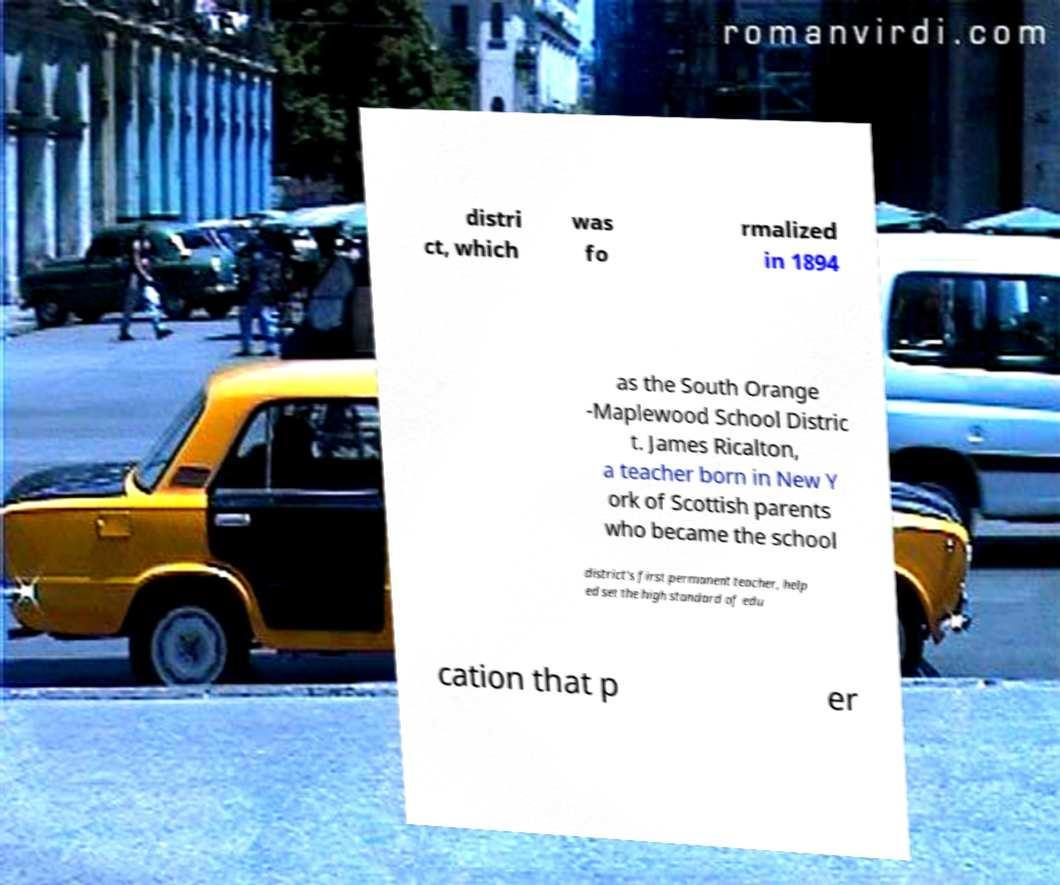Please read and relay the text visible in this image. What does it say? distri ct, which was fo rmalized in 1894 as the South Orange -Maplewood School Distric t. James Ricalton, a teacher born in New Y ork of Scottish parents who became the school district's first permanent teacher, help ed set the high standard of edu cation that p er 